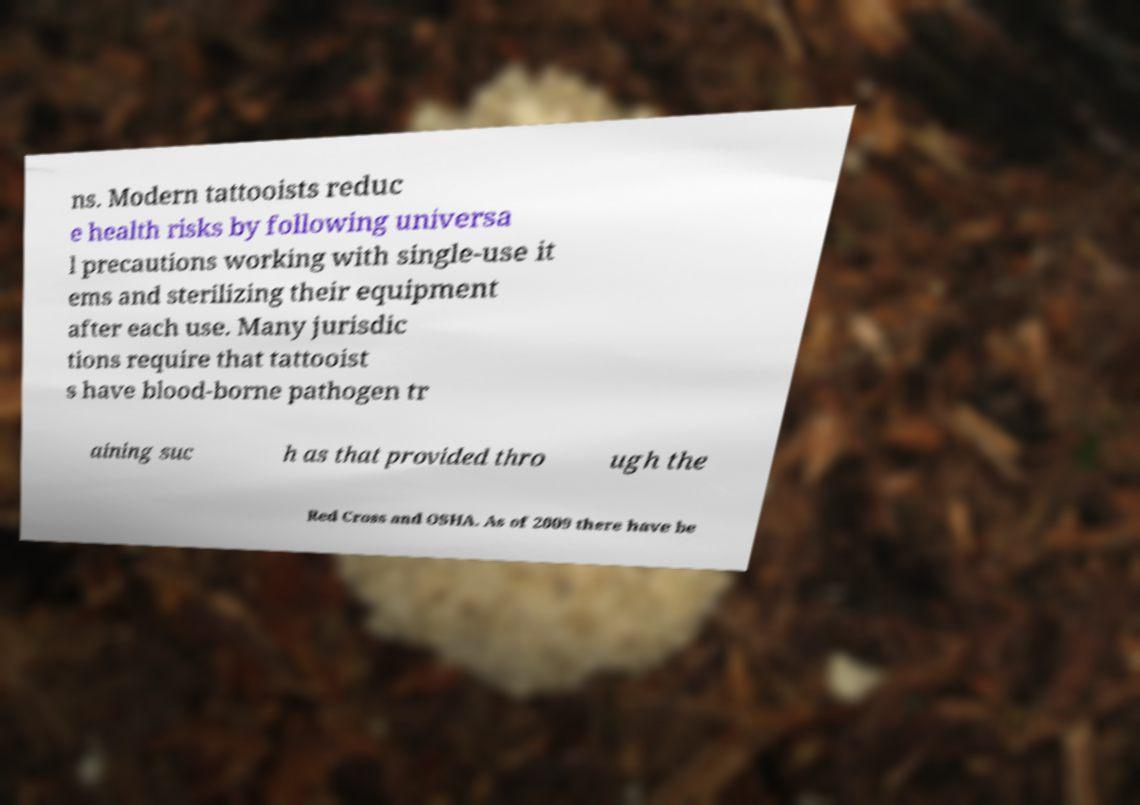There's text embedded in this image that I need extracted. Can you transcribe it verbatim? ns. Modern tattooists reduc e health risks by following universa l precautions working with single-use it ems and sterilizing their equipment after each use. Many jurisdic tions require that tattooist s have blood-borne pathogen tr aining suc h as that provided thro ugh the Red Cross and OSHA. As of 2009 there have be 